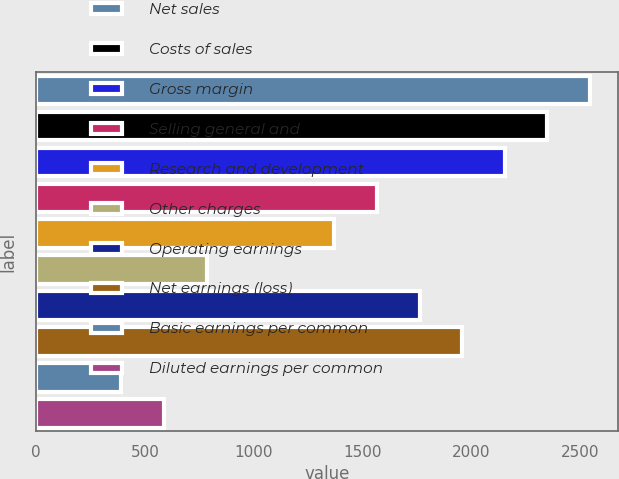Convert chart to OTSL. <chart><loc_0><loc_0><loc_500><loc_500><bar_chart><fcel>Net sales<fcel>Costs of sales<fcel>Gross margin<fcel>Selling general and<fcel>Research and development<fcel>Other charges<fcel>Operating earnings<fcel>Net earnings (loss)<fcel>Basic earnings per common<fcel>Diluted earnings per common<nl><fcel>2543.92<fcel>2348.27<fcel>2152.62<fcel>1565.67<fcel>1370.02<fcel>783.07<fcel>1761.32<fcel>1956.97<fcel>391.77<fcel>587.42<nl></chart> 